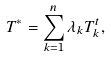<formula> <loc_0><loc_0><loc_500><loc_500>T ^ { * } = \sum _ { k = 1 } ^ { n } \lambda _ { k } T _ { k } ^ { t } ,</formula> 